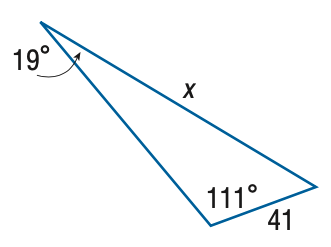Answer the mathemtical geometry problem and directly provide the correct option letter.
Question: Find x. Round the side measure to the nearest tenth.
Choices: A: 14.3 B: 17.4 C: 96.5 D: 117.6 D 